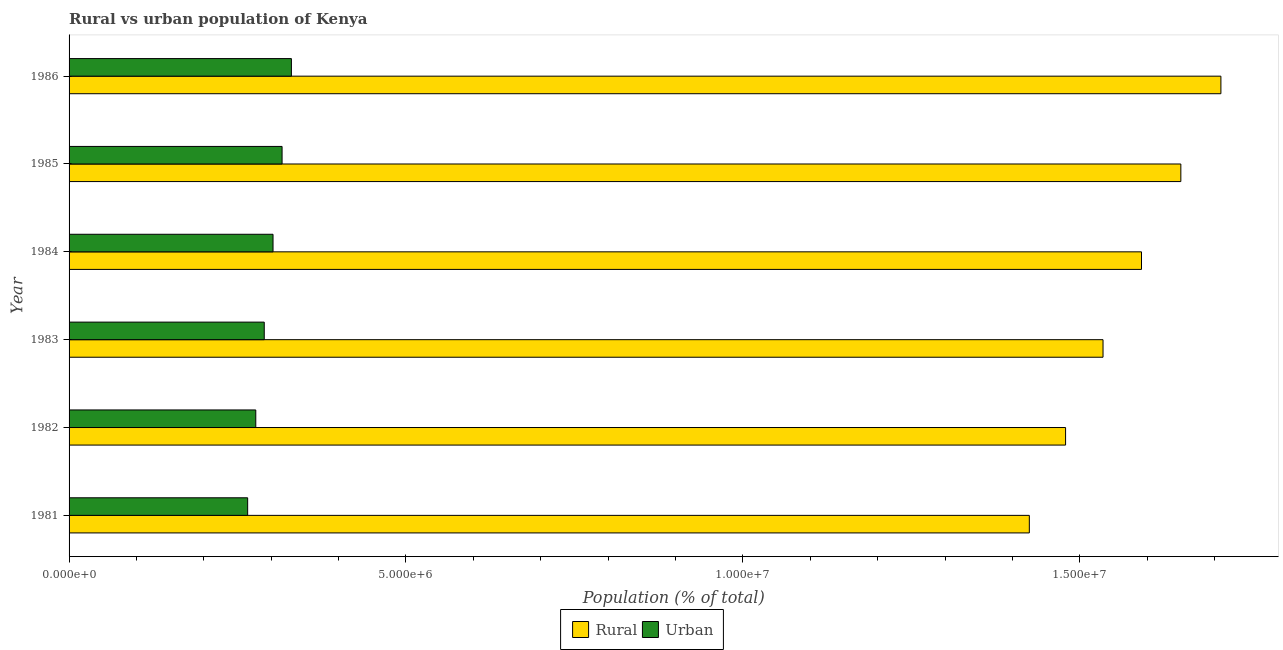How many different coloured bars are there?
Offer a very short reply. 2. How many groups of bars are there?
Keep it short and to the point. 6. Are the number of bars on each tick of the Y-axis equal?
Give a very brief answer. Yes. What is the label of the 1st group of bars from the top?
Ensure brevity in your answer.  1986. In how many cases, is the number of bars for a given year not equal to the number of legend labels?
Keep it short and to the point. 0. What is the urban population density in 1983?
Provide a short and direct response. 2.90e+06. Across all years, what is the maximum rural population density?
Provide a short and direct response. 1.71e+07. Across all years, what is the minimum rural population density?
Offer a very short reply. 1.43e+07. In which year was the urban population density minimum?
Your answer should be very brief. 1981. What is the total urban population density in the graph?
Your answer should be compact. 1.78e+07. What is the difference between the urban population density in 1982 and that in 1986?
Offer a very short reply. -5.29e+05. What is the difference between the urban population density in 1984 and the rural population density in 1983?
Offer a very short reply. -1.23e+07. What is the average urban population density per year?
Your answer should be very brief. 2.97e+06. In the year 1986, what is the difference between the urban population density and rural population density?
Keep it short and to the point. -1.38e+07. In how many years, is the rural population density greater than 5000000 %?
Make the answer very short. 6. What is the ratio of the urban population density in 1981 to that in 1983?
Provide a succinct answer. 0.92. Is the rural population density in 1981 less than that in 1986?
Offer a very short reply. Yes. What is the difference between the highest and the second highest rural population density?
Offer a terse response. 5.95e+05. What is the difference between the highest and the lowest rural population density?
Provide a succinct answer. 2.84e+06. Is the sum of the rural population density in 1983 and 1985 greater than the maximum urban population density across all years?
Provide a succinct answer. Yes. What does the 2nd bar from the top in 1981 represents?
Ensure brevity in your answer.  Rural. What does the 1st bar from the bottom in 1984 represents?
Offer a very short reply. Rural. How many bars are there?
Give a very brief answer. 12. What is the difference between two consecutive major ticks on the X-axis?
Your answer should be very brief. 5.00e+06. Does the graph contain grids?
Offer a very short reply. No. Where does the legend appear in the graph?
Keep it short and to the point. Bottom center. What is the title of the graph?
Keep it short and to the point. Rural vs urban population of Kenya. What is the label or title of the X-axis?
Offer a very short reply. Population (% of total). What is the Population (% of total) in Rural in 1981?
Your answer should be compact. 1.43e+07. What is the Population (% of total) in Urban in 1981?
Your answer should be very brief. 2.65e+06. What is the Population (% of total) in Rural in 1982?
Offer a very short reply. 1.48e+07. What is the Population (% of total) of Urban in 1982?
Provide a short and direct response. 2.77e+06. What is the Population (% of total) in Rural in 1983?
Ensure brevity in your answer.  1.53e+07. What is the Population (% of total) in Urban in 1983?
Make the answer very short. 2.90e+06. What is the Population (% of total) in Rural in 1984?
Provide a succinct answer. 1.59e+07. What is the Population (% of total) of Urban in 1984?
Offer a very short reply. 3.03e+06. What is the Population (% of total) in Rural in 1985?
Ensure brevity in your answer.  1.65e+07. What is the Population (% of total) in Urban in 1985?
Provide a short and direct response. 3.16e+06. What is the Population (% of total) in Rural in 1986?
Provide a succinct answer. 1.71e+07. What is the Population (% of total) of Urban in 1986?
Ensure brevity in your answer.  3.30e+06. Across all years, what is the maximum Population (% of total) of Rural?
Provide a short and direct response. 1.71e+07. Across all years, what is the maximum Population (% of total) of Urban?
Offer a terse response. 3.30e+06. Across all years, what is the minimum Population (% of total) in Rural?
Make the answer very short. 1.43e+07. Across all years, what is the minimum Population (% of total) in Urban?
Your answer should be compact. 2.65e+06. What is the total Population (% of total) in Rural in the graph?
Provide a short and direct response. 9.39e+07. What is the total Population (% of total) of Urban in the graph?
Provide a short and direct response. 1.78e+07. What is the difference between the Population (% of total) in Rural in 1981 and that in 1982?
Make the answer very short. -5.38e+05. What is the difference between the Population (% of total) of Urban in 1981 and that in 1982?
Provide a short and direct response. -1.21e+05. What is the difference between the Population (% of total) of Rural in 1981 and that in 1983?
Your response must be concise. -1.09e+06. What is the difference between the Population (% of total) in Urban in 1981 and that in 1983?
Provide a succinct answer. -2.46e+05. What is the difference between the Population (% of total) of Rural in 1981 and that in 1984?
Provide a succinct answer. -1.66e+06. What is the difference between the Population (% of total) of Urban in 1981 and that in 1984?
Offer a very short reply. -3.77e+05. What is the difference between the Population (% of total) of Rural in 1981 and that in 1985?
Your answer should be compact. -2.25e+06. What is the difference between the Population (% of total) of Urban in 1981 and that in 1985?
Give a very brief answer. -5.11e+05. What is the difference between the Population (% of total) in Rural in 1981 and that in 1986?
Ensure brevity in your answer.  -2.84e+06. What is the difference between the Population (% of total) in Urban in 1981 and that in 1986?
Your answer should be very brief. -6.49e+05. What is the difference between the Population (% of total) of Rural in 1982 and that in 1983?
Ensure brevity in your answer.  -5.56e+05. What is the difference between the Population (% of total) of Urban in 1982 and that in 1983?
Keep it short and to the point. -1.26e+05. What is the difference between the Population (% of total) of Rural in 1982 and that in 1984?
Offer a very short reply. -1.13e+06. What is the difference between the Population (% of total) in Urban in 1982 and that in 1984?
Keep it short and to the point. -2.56e+05. What is the difference between the Population (% of total) of Rural in 1982 and that in 1985?
Give a very brief answer. -1.71e+06. What is the difference between the Population (% of total) in Urban in 1982 and that in 1985?
Provide a short and direct response. -3.90e+05. What is the difference between the Population (% of total) in Rural in 1982 and that in 1986?
Your answer should be very brief. -2.31e+06. What is the difference between the Population (% of total) of Urban in 1982 and that in 1986?
Make the answer very short. -5.29e+05. What is the difference between the Population (% of total) of Rural in 1983 and that in 1984?
Offer a terse response. -5.71e+05. What is the difference between the Population (% of total) in Urban in 1983 and that in 1984?
Provide a succinct answer. -1.30e+05. What is the difference between the Population (% of total) in Rural in 1983 and that in 1985?
Make the answer very short. -1.15e+06. What is the difference between the Population (% of total) of Urban in 1983 and that in 1985?
Keep it short and to the point. -2.65e+05. What is the difference between the Population (% of total) of Rural in 1983 and that in 1986?
Keep it short and to the point. -1.75e+06. What is the difference between the Population (% of total) in Urban in 1983 and that in 1986?
Your answer should be compact. -4.03e+05. What is the difference between the Population (% of total) in Rural in 1984 and that in 1985?
Offer a terse response. -5.84e+05. What is the difference between the Population (% of total) in Urban in 1984 and that in 1985?
Make the answer very short. -1.34e+05. What is the difference between the Population (% of total) of Rural in 1984 and that in 1986?
Ensure brevity in your answer.  -1.18e+06. What is the difference between the Population (% of total) of Urban in 1984 and that in 1986?
Provide a succinct answer. -2.73e+05. What is the difference between the Population (% of total) in Rural in 1985 and that in 1986?
Make the answer very short. -5.95e+05. What is the difference between the Population (% of total) of Urban in 1985 and that in 1986?
Your answer should be compact. -1.38e+05. What is the difference between the Population (% of total) of Rural in 1981 and the Population (% of total) of Urban in 1982?
Keep it short and to the point. 1.15e+07. What is the difference between the Population (% of total) in Rural in 1981 and the Population (% of total) in Urban in 1983?
Provide a short and direct response. 1.14e+07. What is the difference between the Population (% of total) in Rural in 1981 and the Population (% of total) in Urban in 1984?
Provide a short and direct response. 1.12e+07. What is the difference between the Population (% of total) of Rural in 1981 and the Population (% of total) of Urban in 1985?
Your answer should be compact. 1.11e+07. What is the difference between the Population (% of total) of Rural in 1981 and the Population (% of total) of Urban in 1986?
Keep it short and to the point. 1.10e+07. What is the difference between the Population (% of total) of Rural in 1982 and the Population (% of total) of Urban in 1983?
Your answer should be very brief. 1.19e+07. What is the difference between the Population (% of total) of Rural in 1982 and the Population (% of total) of Urban in 1984?
Keep it short and to the point. 1.18e+07. What is the difference between the Population (% of total) in Rural in 1982 and the Population (% of total) in Urban in 1985?
Provide a succinct answer. 1.16e+07. What is the difference between the Population (% of total) of Rural in 1982 and the Population (% of total) of Urban in 1986?
Make the answer very short. 1.15e+07. What is the difference between the Population (% of total) of Rural in 1983 and the Population (% of total) of Urban in 1984?
Keep it short and to the point. 1.23e+07. What is the difference between the Population (% of total) of Rural in 1983 and the Population (% of total) of Urban in 1985?
Give a very brief answer. 1.22e+07. What is the difference between the Population (% of total) of Rural in 1983 and the Population (% of total) of Urban in 1986?
Make the answer very short. 1.20e+07. What is the difference between the Population (% of total) in Rural in 1984 and the Population (% of total) in Urban in 1985?
Offer a very short reply. 1.28e+07. What is the difference between the Population (% of total) in Rural in 1984 and the Population (% of total) in Urban in 1986?
Provide a succinct answer. 1.26e+07. What is the difference between the Population (% of total) of Rural in 1985 and the Population (% of total) of Urban in 1986?
Your response must be concise. 1.32e+07. What is the average Population (% of total) in Rural per year?
Make the answer very short. 1.56e+07. What is the average Population (% of total) of Urban per year?
Provide a succinct answer. 2.97e+06. In the year 1981, what is the difference between the Population (% of total) in Rural and Population (% of total) in Urban?
Give a very brief answer. 1.16e+07. In the year 1982, what is the difference between the Population (% of total) in Rural and Population (% of total) in Urban?
Ensure brevity in your answer.  1.20e+07. In the year 1983, what is the difference between the Population (% of total) in Rural and Population (% of total) in Urban?
Your response must be concise. 1.24e+07. In the year 1984, what is the difference between the Population (% of total) of Rural and Population (% of total) of Urban?
Provide a succinct answer. 1.29e+07. In the year 1985, what is the difference between the Population (% of total) in Rural and Population (% of total) in Urban?
Your answer should be very brief. 1.33e+07. In the year 1986, what is the difference between the Population (% of total) in Rural and Population (% of total) in Urban?
Provide a succinct answer. 1.38e+07. What is the ratio of the Population (% of total) of Rural in 1981 to that in 1982?
Your answer should be compact. 0.96. What is the ratio of the Population (% of total) of Urban in 1981 to that in 1982?
Provide a succinct answer. 0.96. What is the ratio of the Population (% of total) in Rural in 1981 to that in 1983?
Your answer should be very brief. 0.93. What is the ratio of the Population (% of total) of Urban in 1981 to that in 1983?
Make the answer very short. 0.92. What is the ratio of the Population (% of total) of Rural in 1981 to that in 1984?
Your answer should be compact. 0.9. What is the ratio of the Population (% of total) in Urban in 1981 to that in 1984?
Your answer should be very brief. 0.88. What is the ratio of the Population (% of total) in Rural in 1981 to that in 1985?
Provide a short and direct response. 0.86. What is the ratio of the Population (% of total) in Urban in 1981 to that in 1985?
Provide a short and direct response. 0.84. What is the ratio of the Population (% of total) of Rural in 1981 to that in 1986?
Offer a very short reply. 0.83. What is the ratio of the Population (% of total) of Urban in 1981 to that in 1986?
Offer a very short reply. 0.8. What is the ratio of the Population (% of total) in Rural in 1982 to that in 1983?
Provide a short and direct response. 0.96. What is the ratio of the Population (% of total) of Urban in 1982 to that in 1983?
Make the answer very short. 0.96. What is the ratio of the Population (% of total) of Rural in 1982 to that in 1984?
Give a very brief answer. 0.93. What is the ratio of the Population (% of total) in Urban in 1982 to that in 1984?
Your response must be concise. 0.92. What is the ratio of the Population (% of total) in Rural in 1982 to that in 1985?
Provide a short and direct response. 0.9. What is the ratio of the Population (% of total) of Urban in 1982 to that in 1985?
Offer a terse response. 0.88. What is the ratio of the Population (% of total) of Rural in 1982 to that in 1986?
Give a very brief answer. 0.87. What is the ratio of the Population (% of total) in Urban in 1982 to that in 1986?
Your response must be concise. 0.84. What is the ratio of the Population (% of total) in Rural in 1983 to that in 1984?
Provide a short and direct response. 0.96. What is the ratio of the Population (% of total) of Urban in 1983 to that in 1985?
Give a very brief answer. 0.92. What is the ratio of the Population (% of total) in Rural in 1983 to that in 1986?
Provide a short and direct response. 0.9. What is the ratio of the Population (% of total) in Urban in 1983 to that in 1986?
Provide a succinct answer. 0.88. What is the ratio of the Population (% of total) in Rural in 1984 to that in 1985?
Your answer should be compact. 0.96. What is the ratio of the Population (% of total) of Urban in 1984 to that in 1985?
Make the answer very short. 0.96. What is the ratio of the Population (% of total) of Rural in 1984 to that in 1986?
Offer a very short reply. 0.93. What is the ratio of the Population (% of total) in Urban in 1984 to that in 1986?
Your answer should be compact. 0.92. What is the ratio of the Population (% of total) of Rural in 1985 to that in 1986?
Provide a short and direct response. 0.97. What is the ratio of the Population (% of total) in Urban in 1985 to that in 1986?
Ensure brevity in your answer.  0.96. What is the difference between the highest and the second highest Population (% of total) in Rural?
Your answer should be very brief. 5.95e+05. What is the difference between the highest and the second highest Population (% of total) of Urban?
Give a very brief answer. 1.38e+05. What is the difference between the highest and the lowest Population (% of total) in Rural?
Give a very brief answer. 2.84e+06. What is the difference between the highest and the lowest Population (% of total) in Urban?
Your answer should be compact. 6.49e+05. 